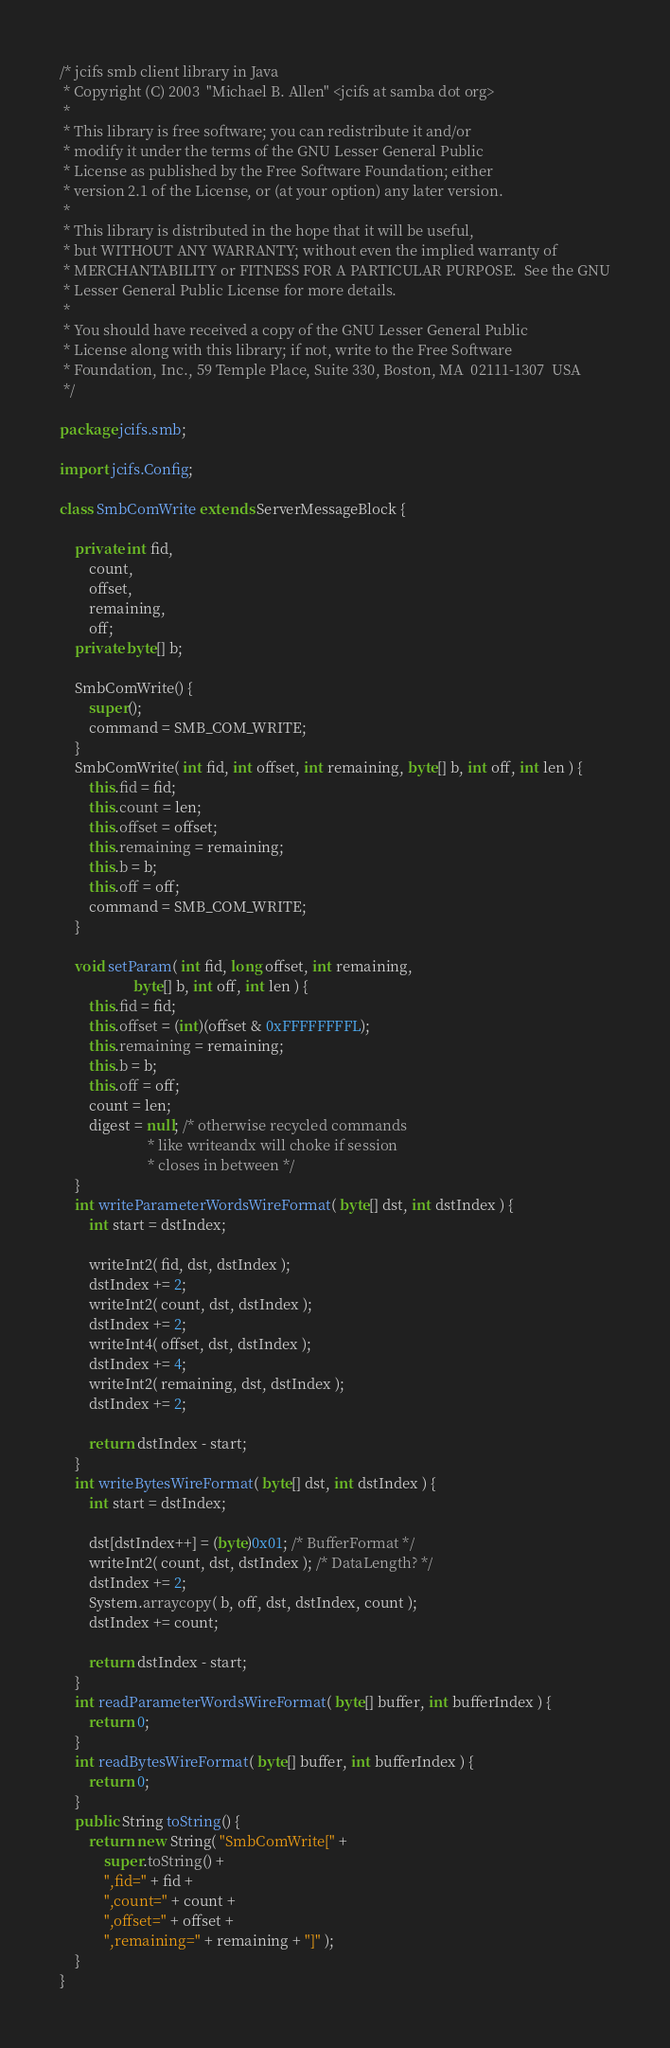Convert code to text. <code><loc_0><loc_0><loc_500><loc_500><_Java_>/* jcifs smb client library in Java
 * Copyright (C) 2003  "Michael B. Allen" <jcifs at samba dot org>
 * 
 * This library is free software; you can redistribute it and/or
 * modify it under the terms of the GNU Lesser General Public
 * License as published by the Free Software Foundation; either
 * version 2.1 of the License, or (at your option) any later version.
 * 
 * This library is distributed in the hope that it will be useful,
 * but WITHOUT ANY WARRANTY; without even the implied warranty of
 * MERCHANTABILITY or FITNESS FOR A PARTICULAR PURPOSE.  See the GNU
 * Lesser General Public License for more details.
 * 
 * You should have received a copy of the GNU Lesser General Public
 * License along with this library; if not, write to the Free Software
 * Foundation, Inc., 59 Temple Place, Suite 330, Boston, MA  02111-1307  USA
 */

package jcifs.smb;

import jcifs.Config;

class SmbComWrite extends ServerMessageBlock {

    private int fid,
        count,
        offset,
        remaining,
        off;
    private byte[] b;

    SmbComWrite() {
        super();
        command = SMB_COM_WRITE;
    }
    SmbComWrite( int fid, int offset, int remaining, byte[] b, int off, int len ) {
        this.fid = fid;
        this.count = len;
        this.offset = offset;
        this.remaining = remaining;
        this.b = b;
        this.off = off;
        command = SMB_COM_WRITE;
    }

    void setParam( int fid, long offset, int remaining,
                    byte[] b, int off, int len ) {
        this.fid = fid;
        this.offset = (int)(offset & 0xFFFFFFFFL);
        this.remaining = remaining;
        this.b = b;
        this.off = off;
        count = len;
        digest = null; /* otherwise recycled commands
                        * like writeandx will choke if session
                        * closes in between */
    }
    int writeParameterWordsWireFormat( byte[] dst, int dstIndex ) {
        int start = dstIndex;

        writeInt2( fid, dst, dstIndex );
        dstIndex += 2;
        writeInt2( count, dst, dstIndex );
        dstIndex += 2;
        writeInt4( offset, dst, dstIndex );
        dstIndex += 4;
        writeInt2( remaining, dst, dstIndex );
        dstIndex += 2;

        return dstIndex - start;
    }
    int writeBytesWireFormat( byte[] dst, int dstIndex ) {
        int start = dstIndex;

        dst[dstIndex++] = (byte)0x01; /* BufferFormat */
        writeInt2( count, dst, dstIndex ); /* DataLength? */
        dstIndex += 2;
        System.arraycopy( b, off, dst, dstIndex, count );
        dstIndex += count;

        return dstIndex - start;
    }
    int readParameterWordsWireFormat( byte[] buffer, int bufferIndex ) {
        return 0;
    }
    int readBytesWireFormat( byte[] buffer, int bufferIndex ) {
        return 0;
    }
    public String toString() {
        return new String( "SmbComWrite[" +
            super.toString() +
            ",fid=" + fid +
            ",count=" + count +
            ",offset=" + offset +
            ",remaining=" + remaining + "]" );
    }
}
</code> 